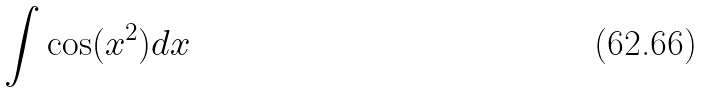<formula> <loc_0><loc_0><loc_500><loc_500>\int \cos ( x ^ { 2 } ) d x</formula> 